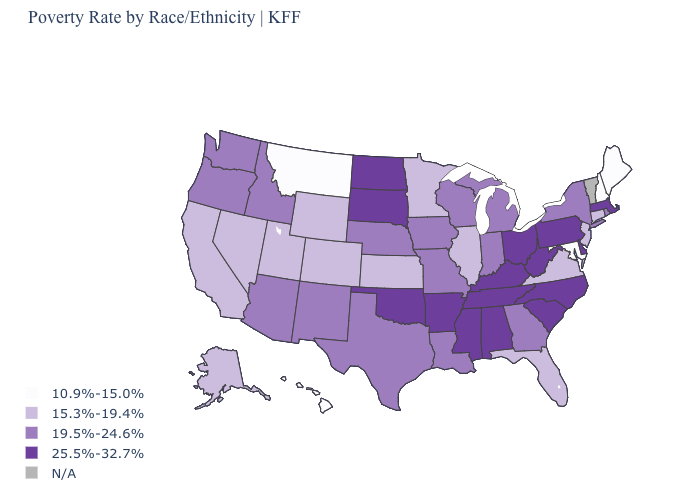Name the states that have a value in the range N/A?
Be succinct. Vermont. What is the lowest value in the USA?
Be succinct. 10.9%-15.0%. What is the highest value in the USA?
Short answer required. 25.5%-32.7%. How many symbols are there in the legend?
Keep it brief. 5. Which states have the highest value in the USA?
Quick response, please. Alabama, Arkansas, Delaware, Kentucky, Massachusetts, Mississippi, North Carolina, North Dakota, Ohio, Oklahoma, Pennsylvania, South Carolina, South Dakota, Tennessee, West Virginia. Does the first symbol in the legend represent the smallest category?
Be succinct. Yes. What is the lowest value in the USA?
Short answer required. 10.9%-15.0%. Is the legend a continuous bar?
Be succinct. No. Does the first symbol in the legend represent the smallest category?
Short answer required. Yes. What is the value of Georgia?
Give a very brief answer. 19.5%-24.6%. Does Maryland have the lowest value in the USA?
Be succinct. Yes. Name the states that have a value in the range 10.9%-15.0%?
Give a very brief answer. Hawaii, Maine, Maryland, Montana, New Hampshire. Which states have the highest value in the USA?
Give a very brief answer. Alabama, Arkansas, Delaware, Kentucky, Massachusetts, Mississippi, North Carolina, North Dakota, Ohio, Oklahoma, Pennsylvania, South Carolina, South Dakota, Tennessee, West Virginia. What is the highest value in states that border Vermont?
Be succinct. 25.5%-32.7%. Among the states that border Michigan , does Ohio have the lowest value?
Write a very short answer. No. 